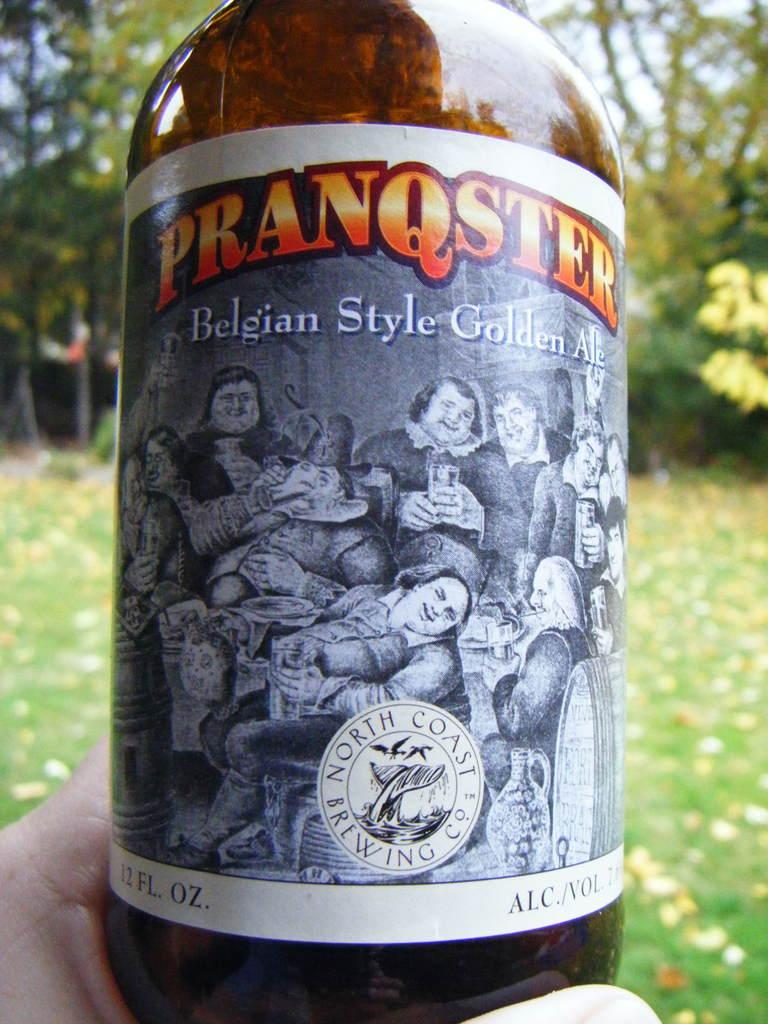<image>
Render a clear and concise summary of the photo. A bottle with quirky picture filled with golden ale. 